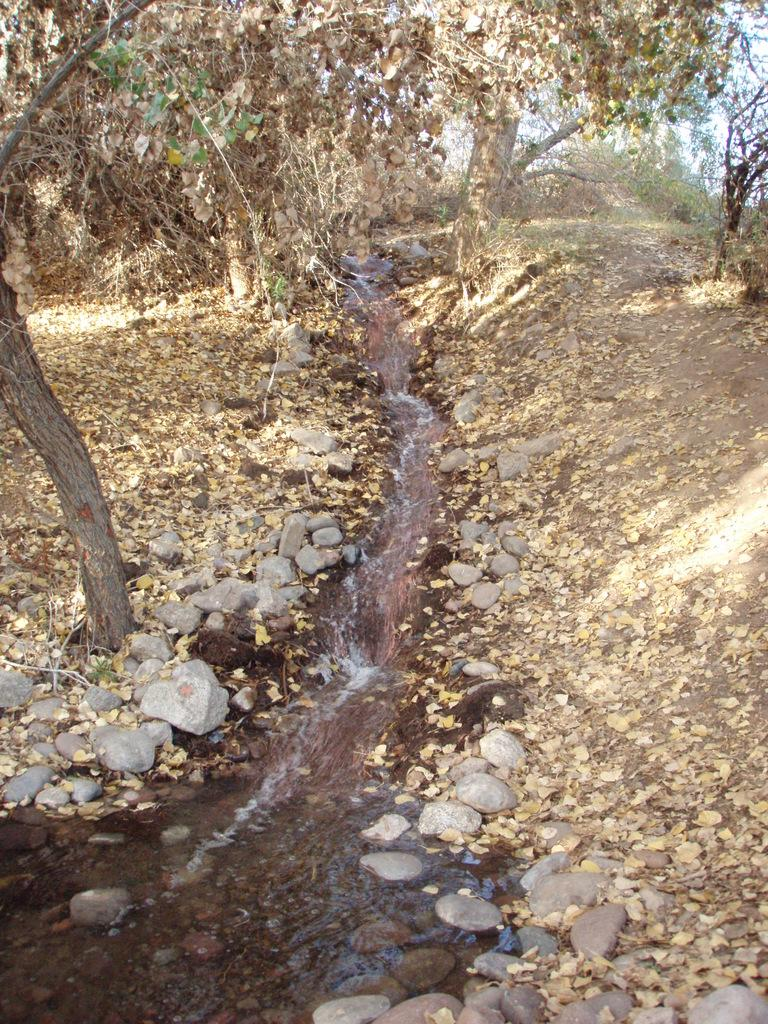What is happening in the picture? There is water flow in the picture. What can be seen on the ground in the picture? Dry leaves and stones are present in the picture. What type of vegetation is visible in the picture? Trees are visible in the picture. What is visible in the background of the picture? The sky is visible in the background of the picture. What type of industry can be seen in the background of the picture? There is no industry present in the image; it features water flow, dry leaves, stones, trees, and the sky. 